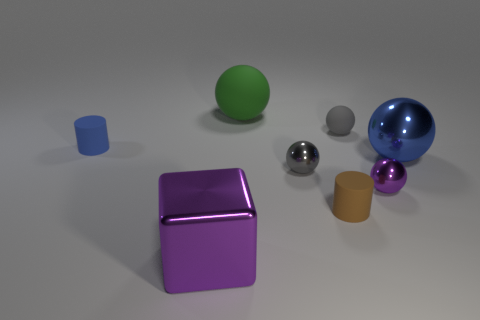Is there any other thing that is the same shape as the big purple thing?
Offer a very short reply. No. How big is the matte object to the left of the big green matte thing?
Your answer should be compact. Small. How many other things are the same color as the large metal cube?
Your answer should be very brief. 1. The large blue object behind the tiny metallic sphere on the left side of the small purple metal ball is made of what material?
Provide a succinct answer. Metal. Do the small cylinder that is right of the tiny blue matte thing and the cube have the same color?
Provide a succinct answer. No. Are there any other things that are the same material as the purple block?
Keep it short and to the point. Yes. What number of other large things have the same shape as the blue matte thing?
Give a very brief answer. 0. There is a brown object that is the same material as the tiny blue object; what size is it?
Provide a short and direct response. Small. There is a large metallic thing behind the purple object on the right side of the small brown object; are there any small purple balls that are on the right side of it?
Give a very brief answer. No. Is the size of the blue metal ball to the right of the green thing the same as the tiny gray metallic object?
Keep it short and to the point. No. 